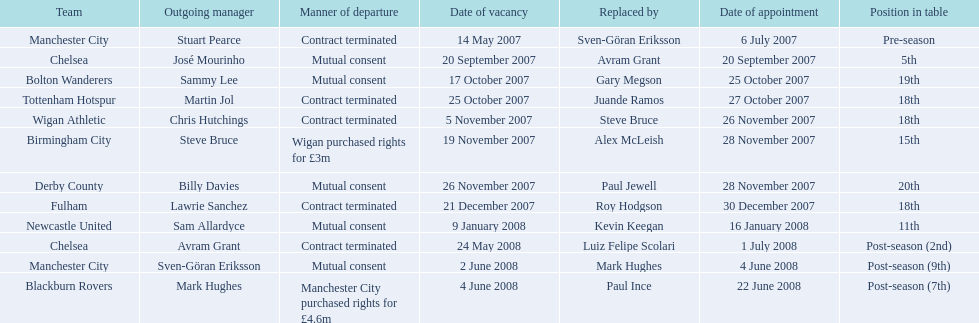What team is listed after manchester city? Chelsea. 